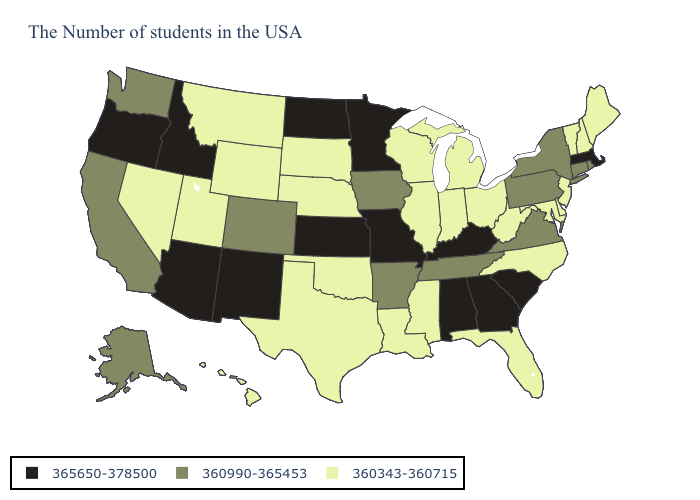Does the first symbol in the legend represent the smallest category?
Give a very brief answer. No. Among the states that border Arizona , does Colorado have the highest value?
Short answer required. No. What is the value of Hawaii?
Write a very short answer. 360343-360715. What is the value of Vermont?
Answer briefly. 360343-360715. Name the states that have a value in the range 360343-360715?
Answer briefly. Maine, New Hampshire, Vermont, New Jersey, Delaware, Maryland, North Carolina, West Virginia, Ohio, Florida, Michigan, Indiana, Wisconsin, Illinois, Mississippi, Louisiana, Nebraska, Oklahoma, Texas, South Dakota, Wyoming, Utah, Montana, Nevada, Hawaii. Among the states that border Arkansas , which have the lowest value?
Concise answer only. Mississippi, Louisiana, Oklahoma, Texas. Does Arizona have a higher value than Kansas?
Be succinct. No. What is the value of Oklahoma?
Keep it brief. 360343-360715. What is the value of South Dakota?
Concise answer only. 360343-360715. What is the highest value in the Northeast ?
Write a very short answer. 365650-378500. Name the states that have a value in the range 365650-378500?
Give a very brief answer. Massachusetts, South Carolina, Georgia, Kentucky, Alabama, Missouri, Minnesota, Kansas, North Dakota, New Mexico, Arizona, Idaho, Oregon. What is the value of Georgia?
Give a very brief answer. 365650-378500. Among the states that border North Dakota , which have the lowest value?
Be succinct. South Dakota, Montana. What is the lowest value in states that border Vermont?
Concise answer only. 360343-360715. What is the value of California?
Be succinct. 360990-365453. 